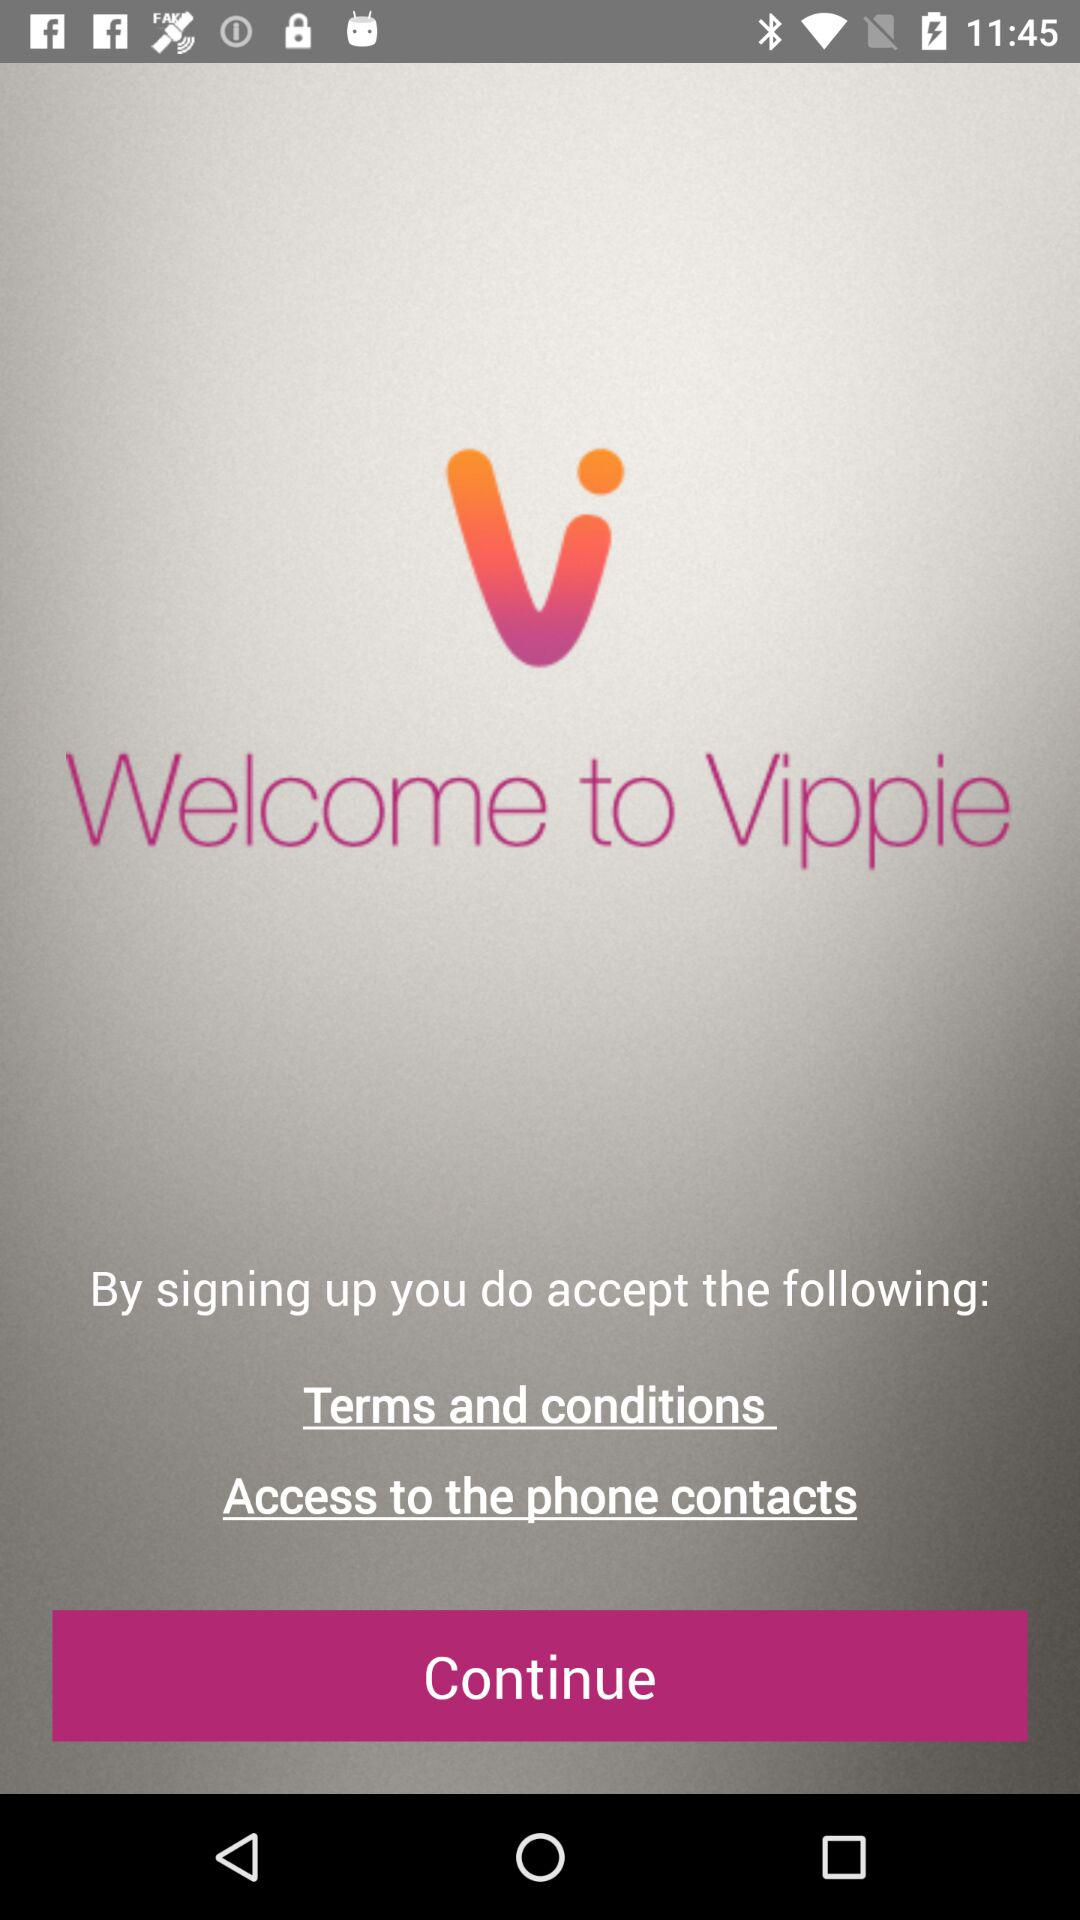What is the name of the application? The name of the application is "Vippie". 